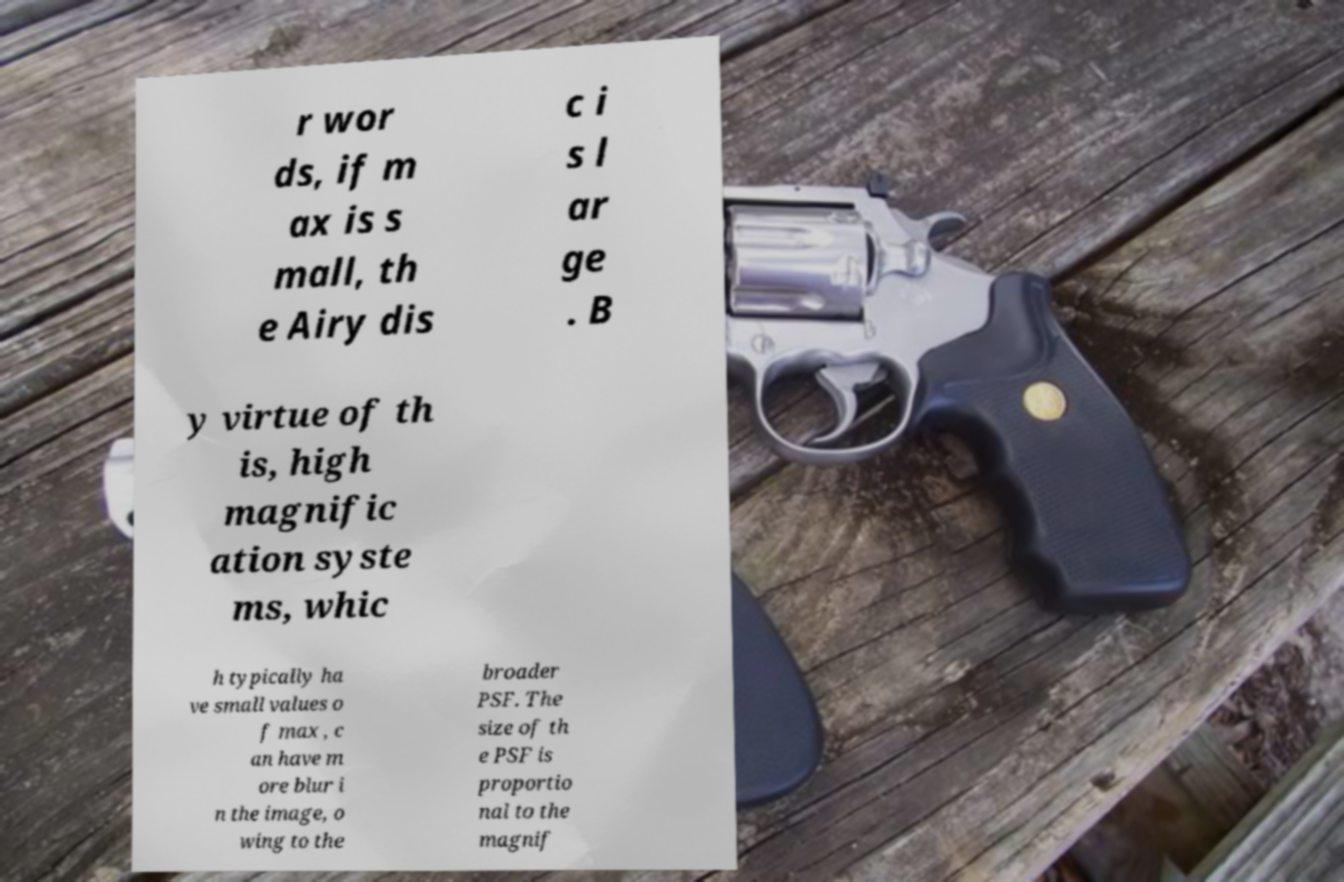Could you extract and type out the text from this image? r wor ds, if m ax is s mall, th e Airy dis c i s l ar ge . B y virtue of th is, high magnific ation syste ms, whic h typically ha ve small values o f max , c an have m ore blur i n the image, o wing to the broader PSF. The size of th e PSF is proportio nal to the magnif 